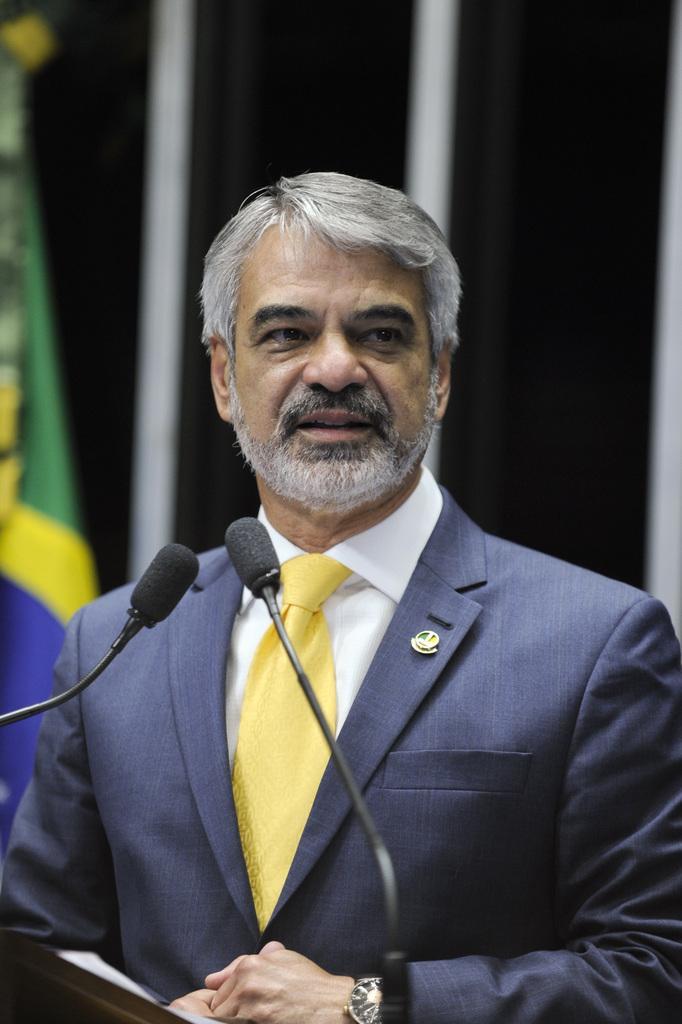Please provide a concise description of this image. In this picture I can see a man is standing in front of microphones. The man is wearing suit, tie, shirt and watch. In the background I can see flag and wall. 